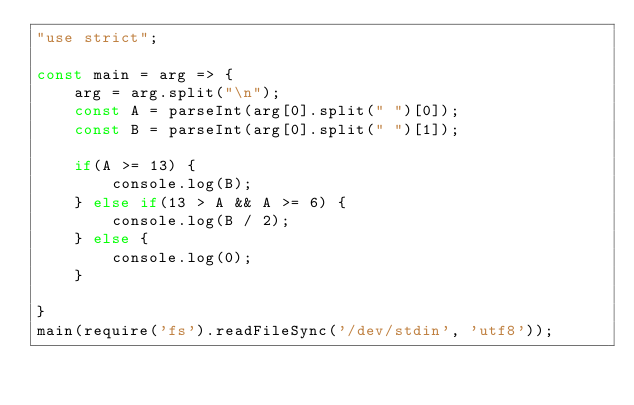<code> <loc_0><loc_0><loc_500><loc_500><_JavaScript_>"use strict";
    
const main = arg => {
    arg = arg.split("\n");
    const A = parseInt(arg[0].split(" ")[0]);
    const B = parseInt(arg[0].split(" ")[1]);
    
    if(A >= 13) {
        console.log(B);
    } else if(13 > A && A >= 6) {
        console.log(B / 2);
    } else {
        console.log(0);
    }
    
}
main(require('fs').readFileSync('/dev/stdin', 'utf8'));</code> 